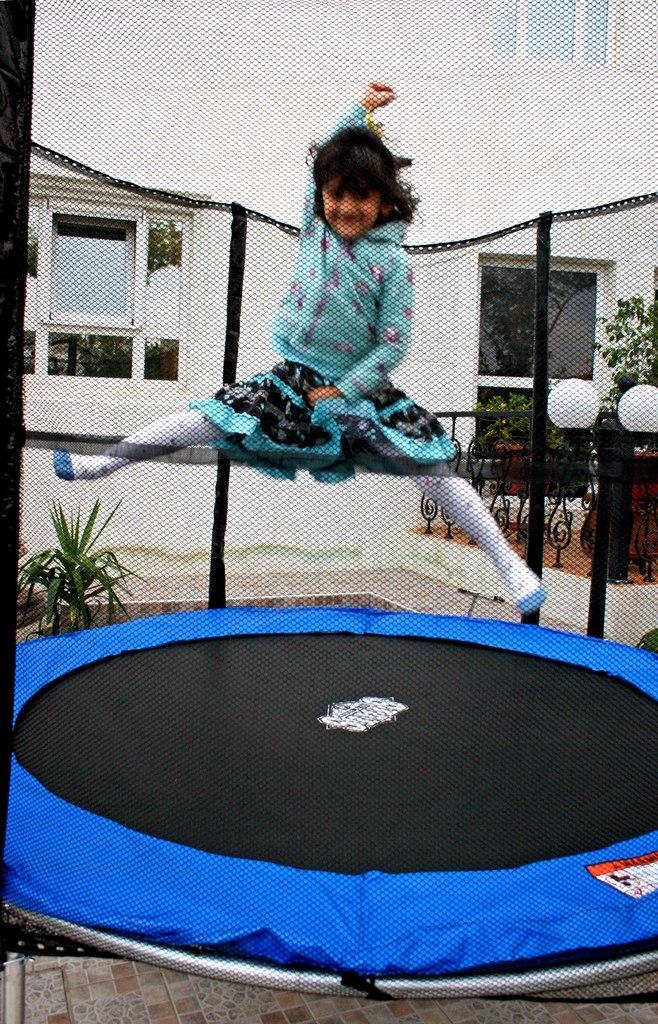Could you give a brief overview of what you see in this image? In the image we can see a girl wearing clothes, she is jumping. This is a net, footpath, light pole, plant, fence, building and window of the building. 